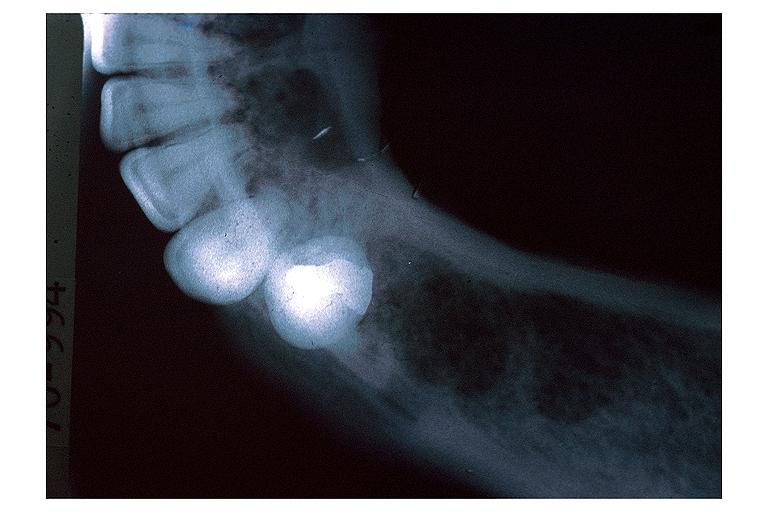does anencephaly show lymphoma?
Answer the question using a single word or phrase. No 